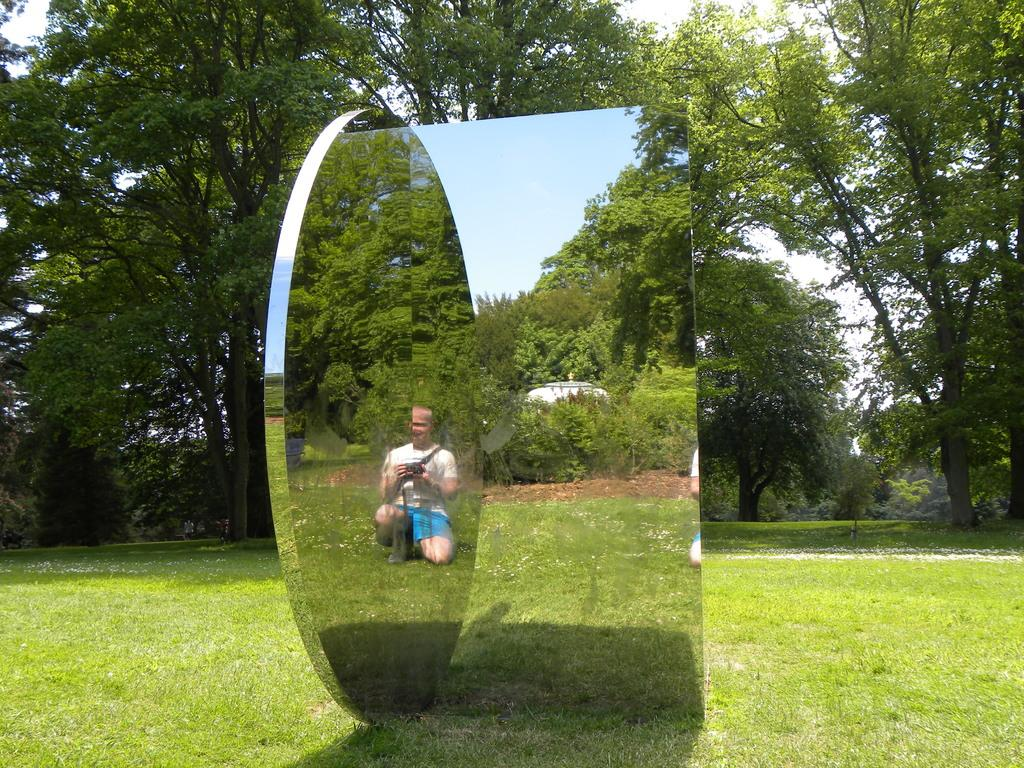What object is placed on the ground in the image? There is a mirror placed on the ground. What can be seen on the ground around the mirror? The ground has greenery. Who or what can be seen in the mirror? A person is visible in the mirror. What is visible in the background of the image? There are trees in the background of the image. How many beads are scattered on the ground in the image? There are no beads visible on the ground in the image. What type of money can be seen in the person's hand in the mirror? There is no money visible in the person's hand in the mirror; only the person's reflection is visible. 